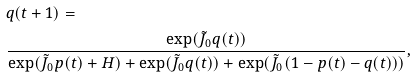<formula> <loc_0><loc_0><loc_500><loc_500>& q ( t + 1 ) = \\ & \frac { \exp ( \tilde { J } _ { 0 } q ( t ) ) } { \exp ( \tilde { J } _ { 0 } p ( t ) + H ) + \exp ( \tilde { J } _ { 0 } q ( t ) ) + \exp ( \tilde { J } _ { 0 } ( 1 - p ( t ) - q ( t ) ) ) } ,</formula> 